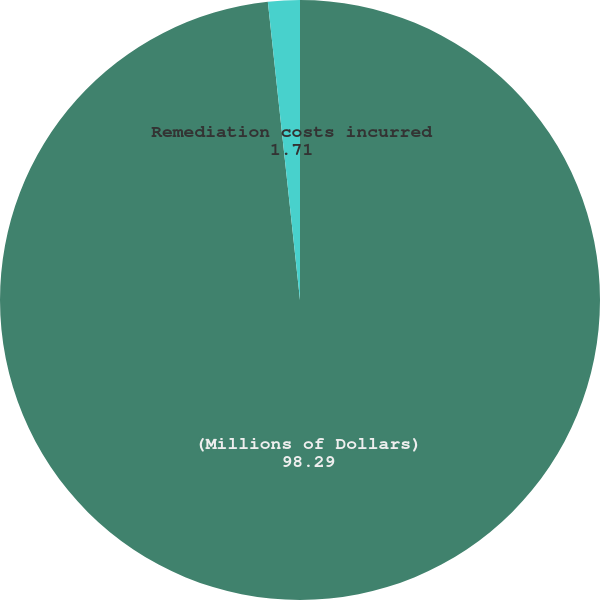Convert chart to OTSL. <chart><loc_0><loc_0><loc_500><loc_500><pie_chart><fcel>(Millions of Dollars)<fcel>Remediation costs incurred<nl><fcel>98.29%<fcel>1.71%<nl></chart> 